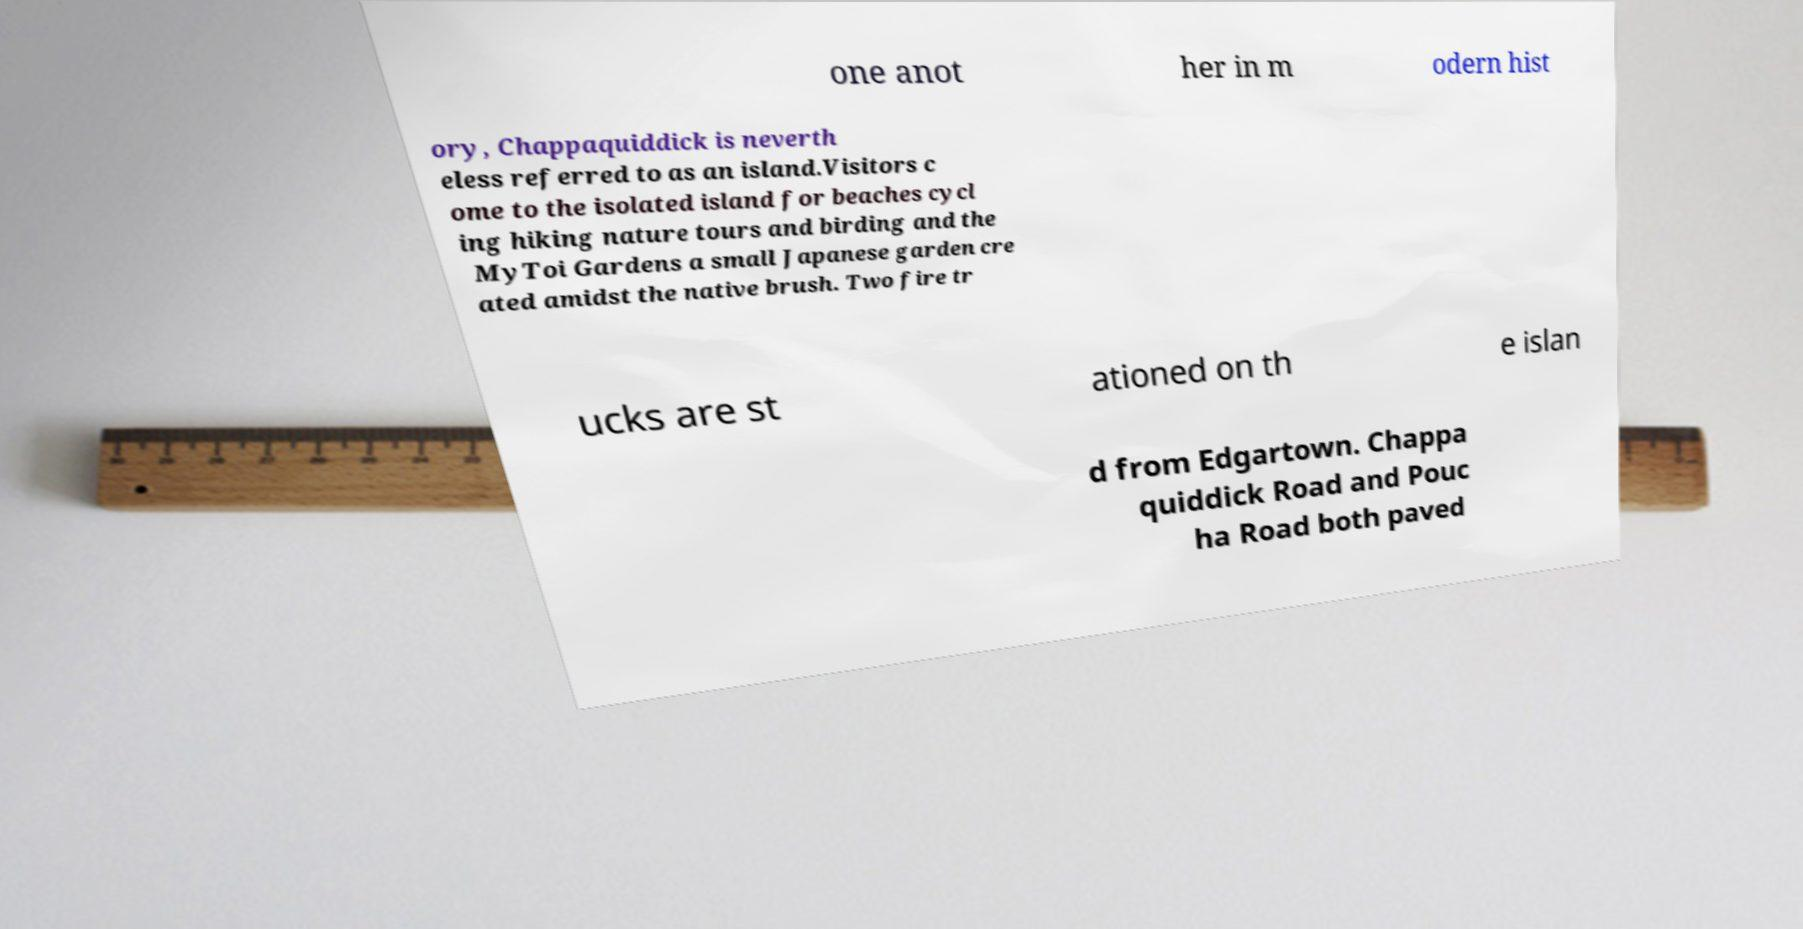For documentation purposes, I need the text within this image transcribed. Could you provide that? one anot her in m odern hist ory, Chappaquiddick is neverth eless referred to as an island.Visitors c ome to the isolated island for beaches cycl ing hiking nature tours and birding and the MyToi Gardens a small Japanese garden cre ated amidst the native brush. Two fire tr ucks are st ationed on th e islan d from Edgartown. Chappa quiddick Road and Pouc ha Road both paved 